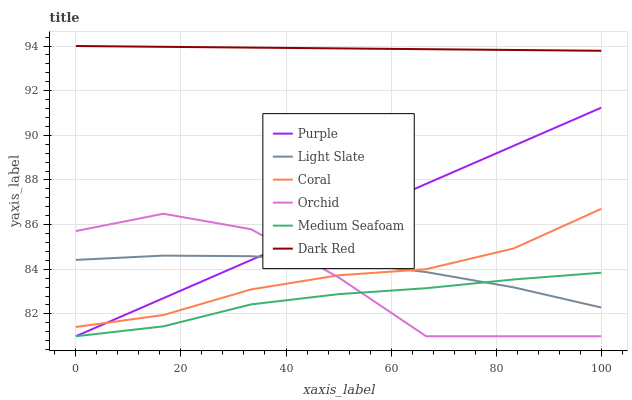Does Medium Seafoam have the minimum area under the curve?
Answer yes or no. Yes. Does Dark Red have the maximum area under the curve?
Answer yes or no. Yes. Does Coral have the minimum area under the curve?
Answer yes or no. No. Does Coral have the maximum area under the curve?
Answer yes or no. No. Is Purple the smoothest?
Answer yes or no. Yes. Is Orchid the roughest?
Answer yes or no. Yes. Is Dark Red the smoothest?
Answer yes or no. No. Is Dark Red the roughest?
Answer yes or no. No. Does Purple have the lowest value?
Answer yes or no. Yes. Does Coral have the lowest value?
Answer yes or no. No. Does Dark Red have the highest value?
Answer yes or no. Yes. Does Coral have the highest value?
Answer yes or no. No. Is Medium Seafoam less than Dark Red?
Answer yes or no. Yes. Is Dark Red greater than Medium Seafoam?
Answer yes or no. Yes. Does Orchid intersect Medium Seafoam?
Answer yes or no. Yes. Is Orchid less than Medium Seafoam?
Answer yes or no. No. Is Orchid greater than Medium Seafoam?
Answer yes or no. No. Does Medium Seafoam intersect Dark Red?
Answer yes or no. No. 